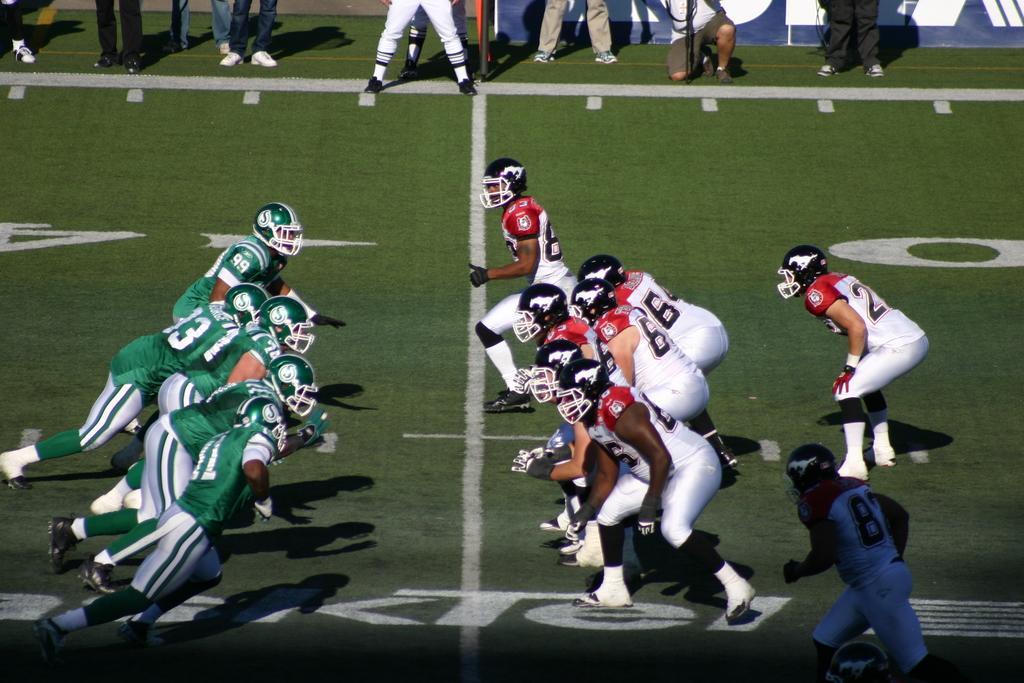Please provide a concise description of this image. In this image I can see people among them this people are wearing helmets. I can also see lines on the ground. 